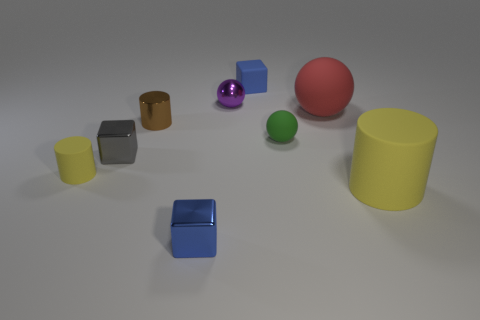What number of rubber things are gray things or small blue objects?
Your answer should be very brief. 1. What is the shape of the small gray thing?
Offer a terse response. Cube. What number of tiny things are made of the same material as the purple ball?
Give a very brief answer. 3. There is a ball that is made of the same material as the brown cylinder; what is its color?
Your answer should be very brief. Purple. There is a brown shiny cylinder in front of the purple ball; is it the same size as the tiny green rubber ball?
Keep it short and to the point. Yes. There is another metallic thing that is the same shape as the tiny blue shiny thing; what color is it?
Offer a terse response. Gray. There is a large rubber object behind the tiny cylinder that is right of the yellow cylinder that is behind the big cylinder; what shape is it?
Provide a succinct answer. Sphere. Is the red thing the same shape as the tiny green matte object?
Provide a succinct answer. Yes. There is a yellow object right of the sphere that is to the left of the tiny blue matte thing; what shape is it?
Your answer should be very brief. Cylinder. Are there any small rubber cylinders?
Your answer should be very brief. Yes. 